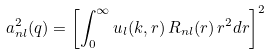<formula> <loc_0><loc_0><loc_500><loc_500>a _ { n l } ^ { 2 } ( q ) = \left [ \int _ { 0 } ^ { \infty } u _ { l } ( k , r ) \, R _ { n l } ( r ) \, r ^ { 2 } d r \right ] ^ { 2 }</formula> 